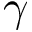<formula> <loc_0><loc_0><loc_500><loc_500>\gamma</formula> 